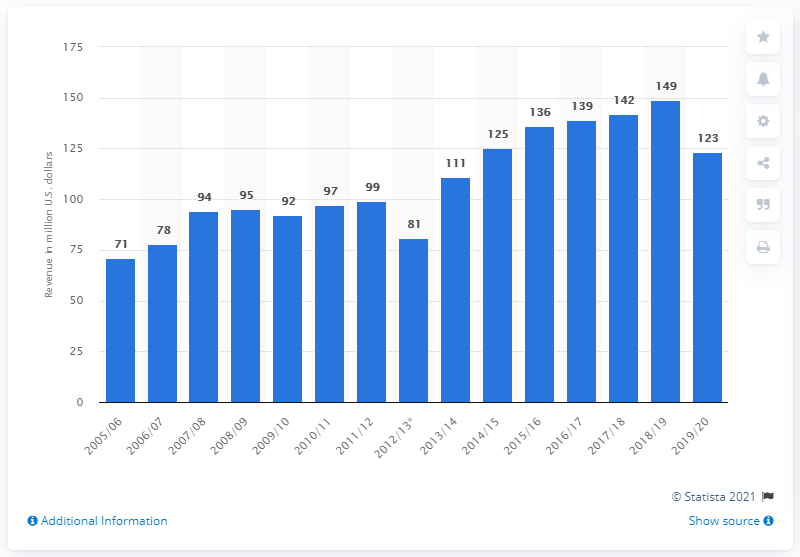List a handful of essential elements in this visual. The Minnesota Wild made a total of $123 million in the 2019/20 season. 